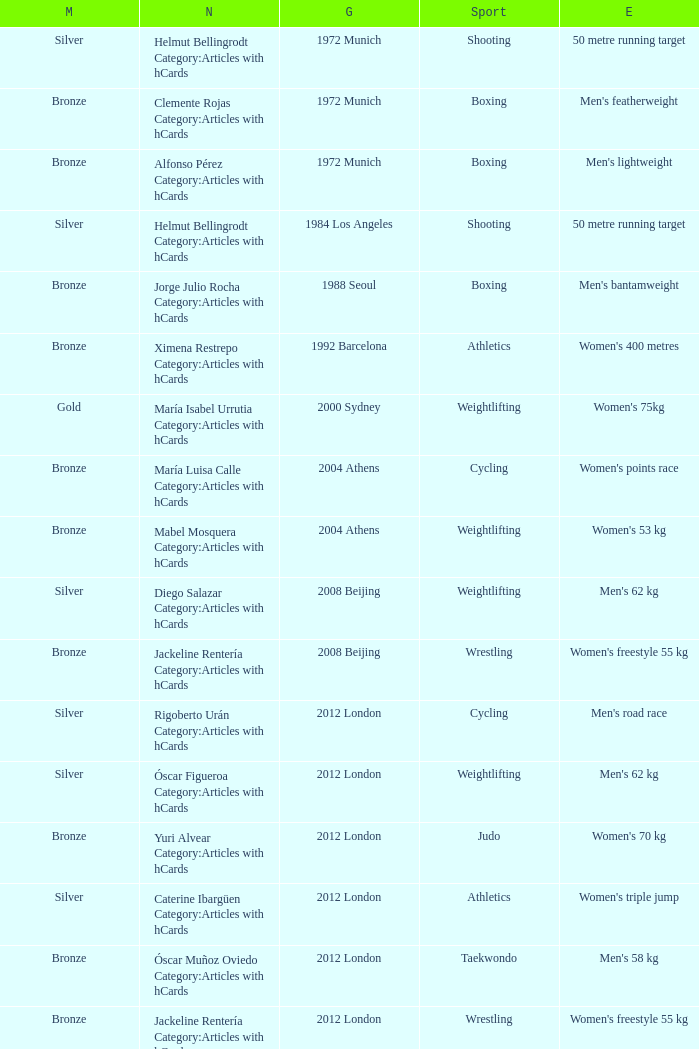Which wrestling event was at the 2008 Beijing games? Women's freestyle 55 kg. 